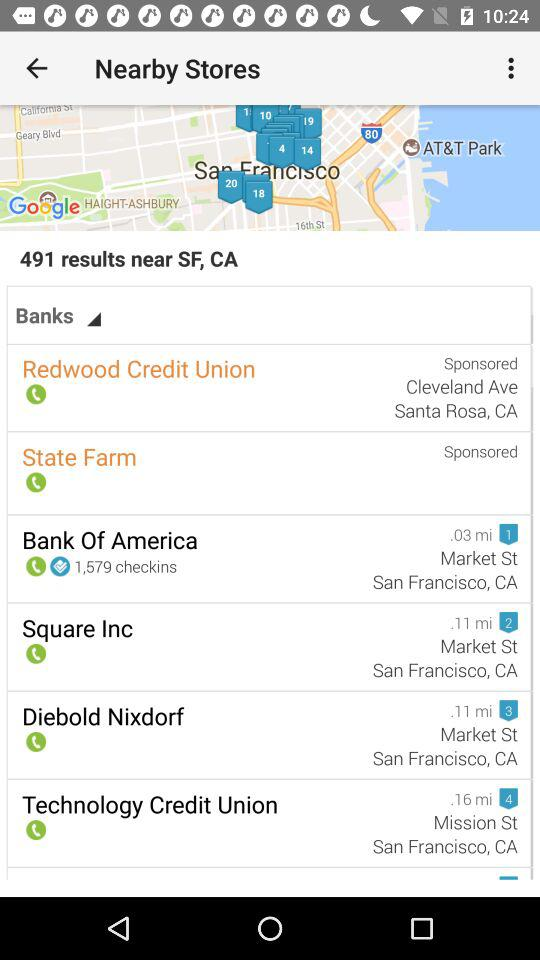What is the number of checkins at "Bank of America"? The number of checkins is 1,579. 